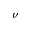Convert formula to latex. <formula><loc_0><loc_0><loc_500><loc_500>\nu</formula> 